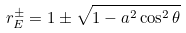<formula> <loc_0><loc_0><loc_500><loc_500>r _ { E } ^ { \pm } = 1 \pm { \sqrt { 1 - a ^ { 2 } \cos ^ { 2 } \theta } }</formula> 